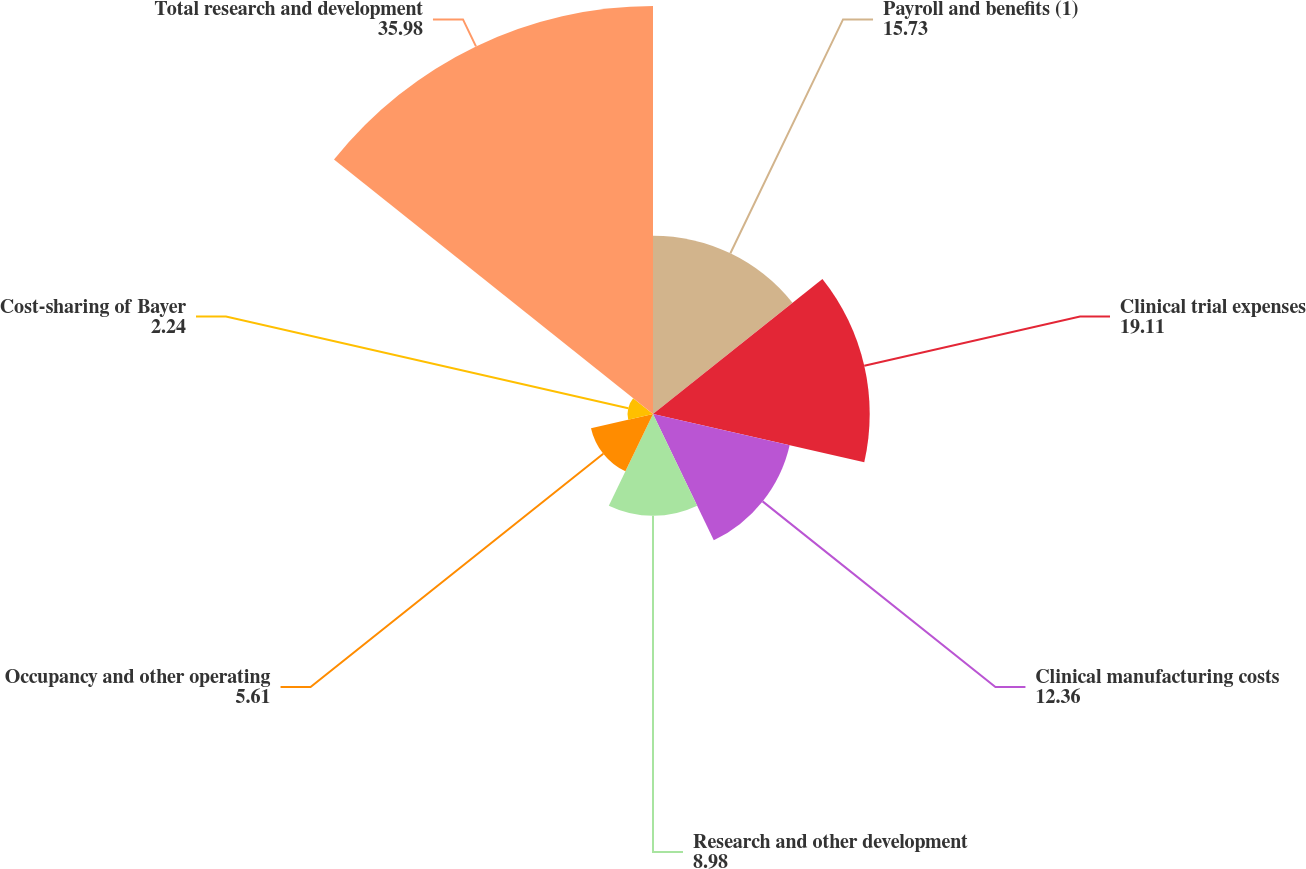<chart> <loc_0><loc_0><loc_500><loc_500><pie_chart><fcel>Payroll and benefits (1)<fcel>Clinical trial expenses<fcel>Clinical manufacturing costs<fcel>Research and other development<fcel>Occupancy and other operating<fcel>Cost-sharing of Bayer<fcel>Total research and development<nl><fcel>15.73%<fcel>19.11%<fcel>12.36%<fcel>8.98%<fcel>5.61%<fcel>2.24%<fcel>35.98%<nl></chart> 